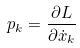Convert formula to latex. <formula><loc_0><loc_0><loc_500><loc_500>p _ { k } = \frac { \partial L } { \partial \dot { x } _ { k } }</formula> 